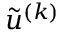Convert formula to latex. <formula><loc_0><loc_0><loc_500><loc_500>\tilde { u } ^ { ( k ) }</formula> 